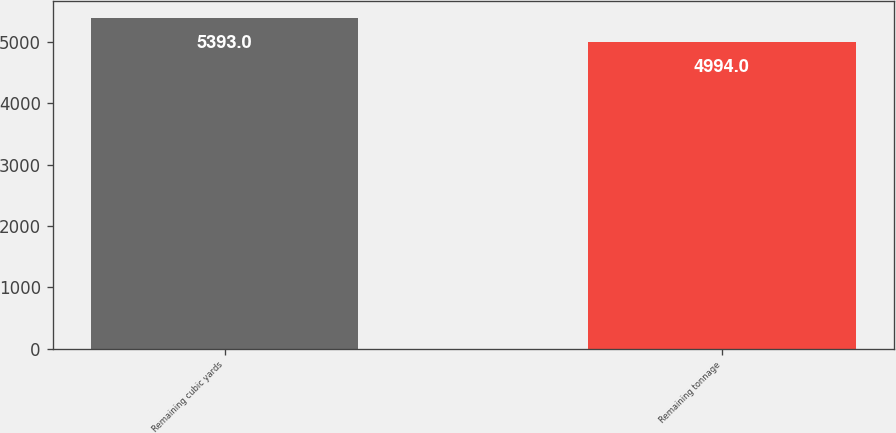Convert chart to OTSL. <chart><loc_0><loc_0><loc_500><loc_500><bar_chart><fcel>Remaining cubic yards<fcel>Remaining tonnage<nl><fcel>5393<fcel>4994<nl></chart> 